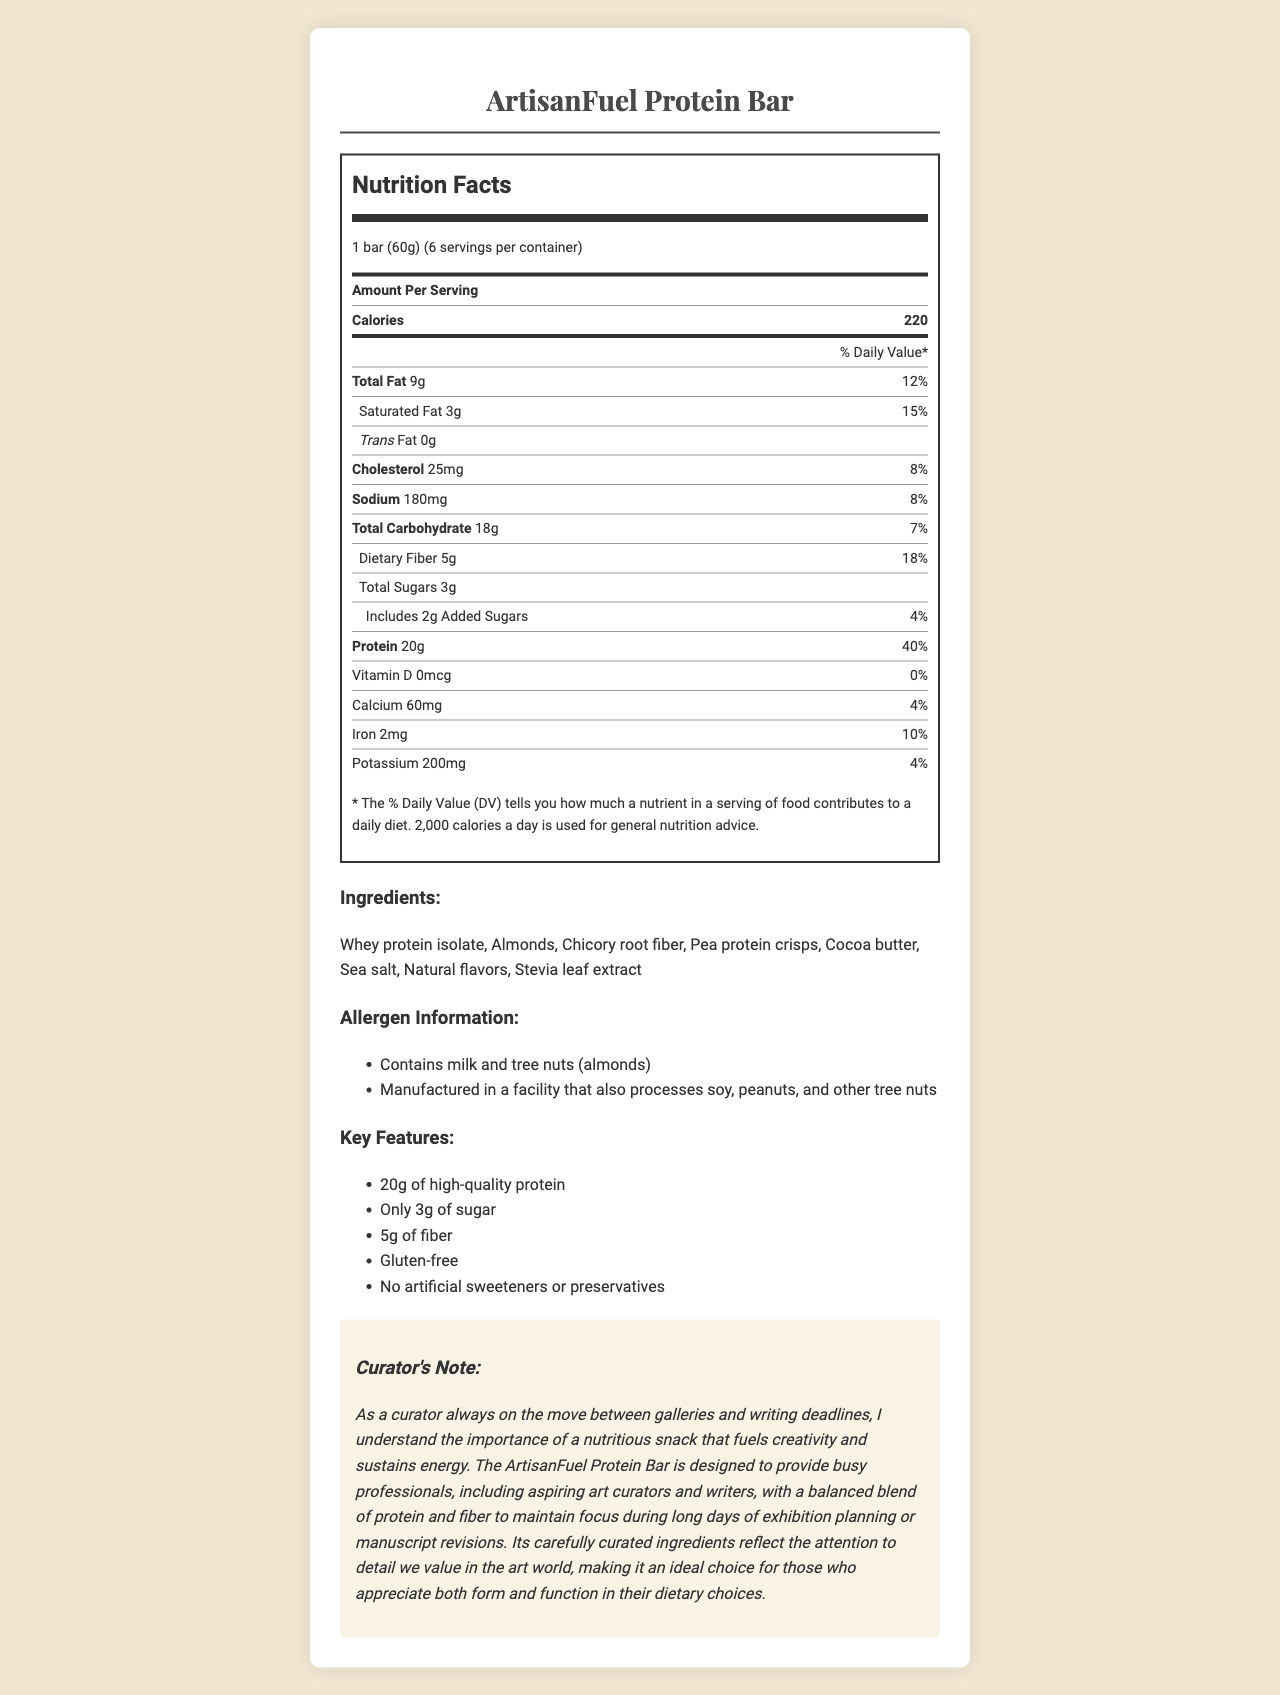what is the serving size of the ArtisanFuel Protein Bar? The serving size is explicitly listed at the beginning of the nutrition facts section.
Answer: 1 bar (60g) how many calories are in one serving of the ArtisanFuel Protein Bar? The calorie count per serving is highlighted under the 'Amount Per Serving' section in the Nutrition Facts.
Answer: 220 calories how many grams of protein does one ArtisanFuel Protein Bar contain? The protein content is listed as 20g under the 'Protein' section of the Nutrition Facts.
Answer: 20g which ingredients listed in the ArtisanFuel Protein Bar may cause allergic reactions? The allergen information section notes that the bar contains milk and tree nuts (almonds).
Answer: Milk and tree nuts (almonds) which mineral contributes 10% to the daily value in the ArtisanFuel Protein Bar? The iron content contributes 10% to the daily value as listed in the Nutrition Facts panel.
Answer: Iron how much dietary fiber is in one ArtisanFuel Protein Bar? The dietary fiber amount is listed as 5g in the Total Carbohydrate section.
Answer: 5g which of the following is a key marketing claim of the ArtisanFuel Protein Bar? A. Contains artificial sweeteners B. High in saturated fat C. Gluten-free D. High in sodium One of the key features specifically mentioned in the document is that the bar is gluten-free.
Answer: C which vitamins or minerals does the ArtisanFuel Protein Bar NOT provide any daily value for? A. Vitamin D B. Calcium C. Iron D. Potassium The Nutrition Facts section shows that Vitamin D has 0% daily value in this product.
Answer: A is the ArtisanFuel Protein Bar suitable for someone trying to avoid soy products? The allergen information states that it is manufactured in a facility that also processes soy.
Answer: No summarize the main idea of the ArtisanFuel Protein Bar document. This summary describes the key nutritional points, marketing claims, and additional information provided about the protein bar.
Answer: The ArtisanFuel Protein Bar is a high-protein, low-carb snack designed for busy professionals, containing 20g of protein, 5g of fiber, and only 3g of sugar per serving. It is gluten-free, free from artificial sweeteners and preservatives, and the document highlights its nutritious composition, ingredients, and allergen warnings as well as key marketing claims and a curator's note emphasizing the attention to detail and quality ingredients. what kind of writing projects might the ArtisanFuel Protein Bar be useful for, according to the curator's note? The curator's note mentions that it is helpful for writing deadlines but does not specify the type of writing projects in detail.
Answer: Not enough information 